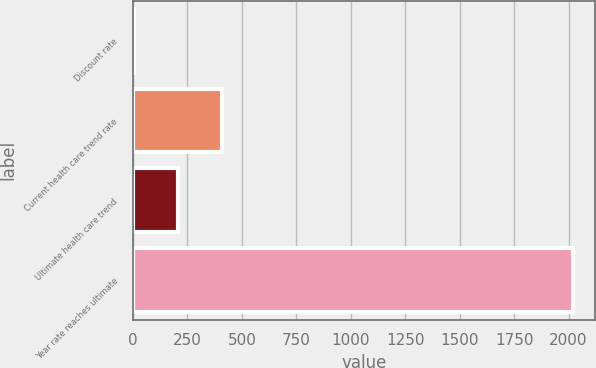Convert chart. <chart><loc_0><loc_0><loc_500><loc_500><bar_chart><fcel>Discount rate<fcel>Current health care trend rate<fcel>Ultimate health care trend<fcel>Year rate reaches ultimate<nl><fcel>3.4<fcel>407.12<fcel>205.26<fcel>2022<nl></chart> 